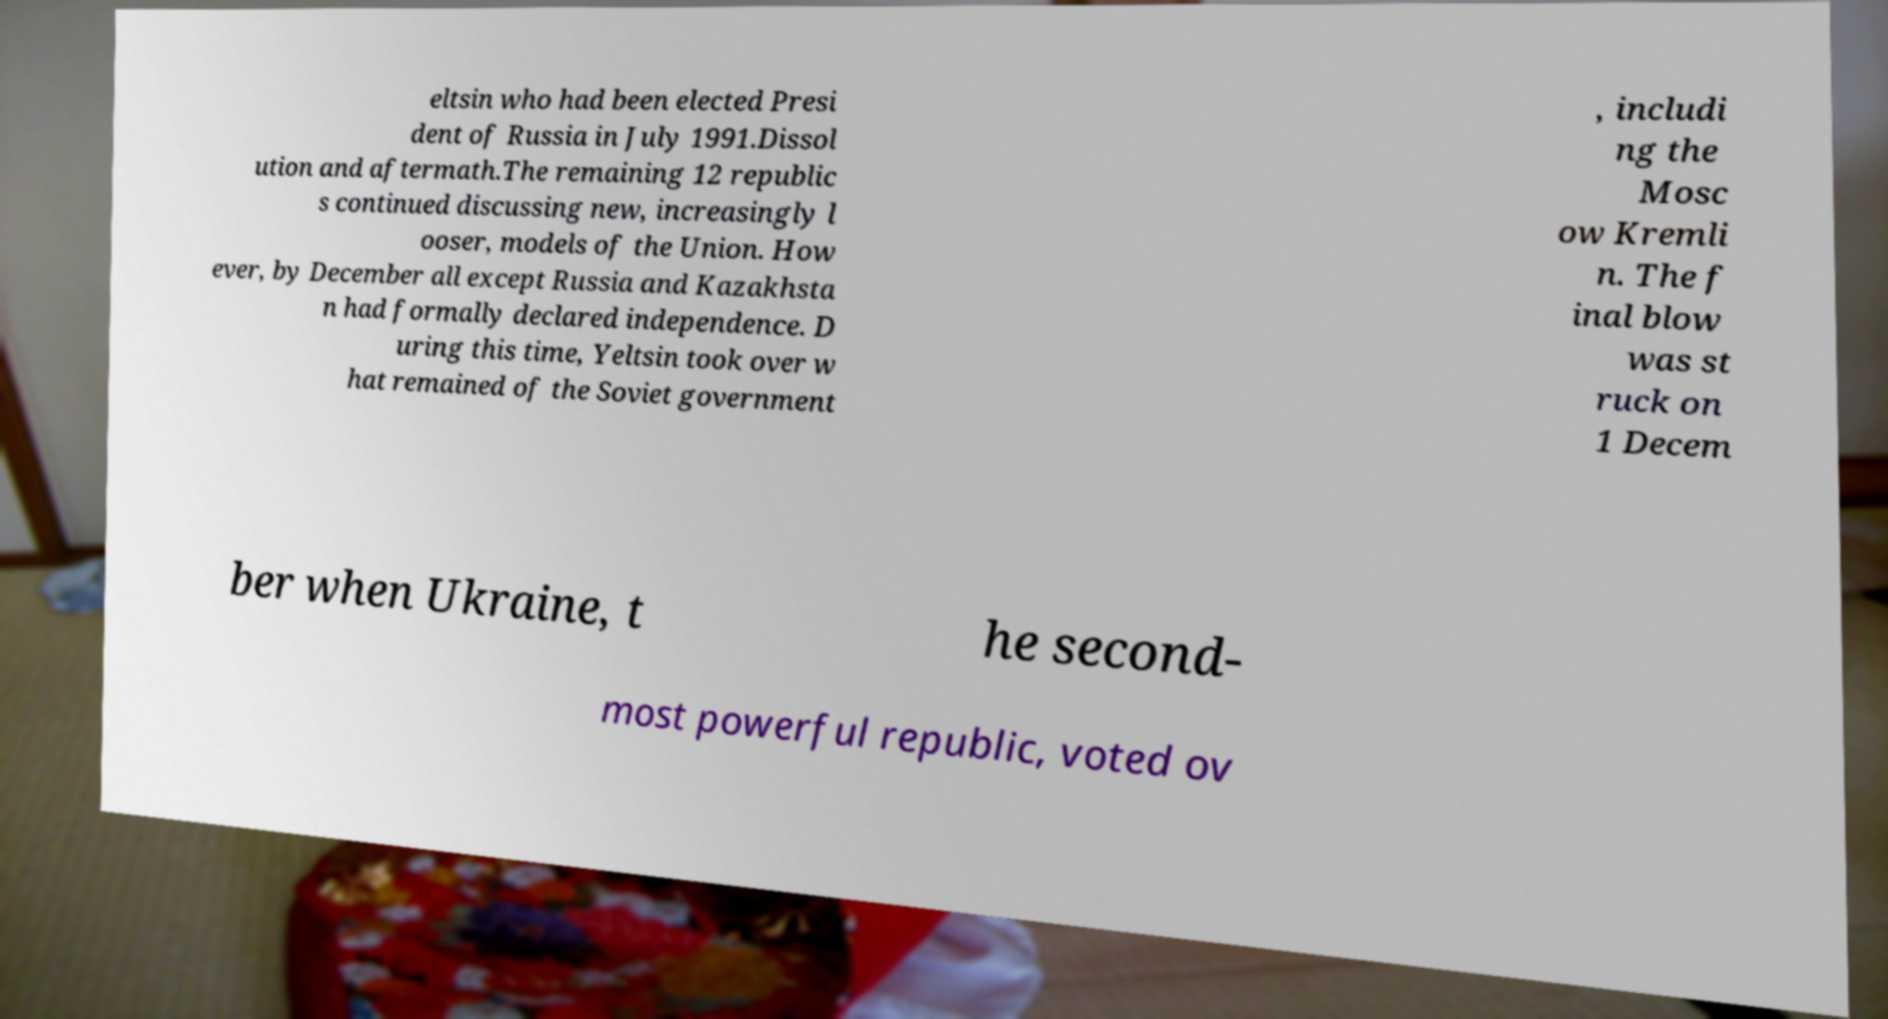I need the written content from this picture converted into text. Can you do that? eltsin who had been elected Presi dent of Russia in July 1991.Dissol ution and aftermath.The remaining 12 republic s continued discussing new, increasingly l ooser, models of the Union. How ever, by December all except Russia and Kazakhsta n had formally declared independence. D uring this time, Yeltsin took over w hat remained of the Soviet government , includi ng the Mosc ow Kremli n. The f inal blow was st ruck on 1 Decem ber when Ukraine, t he second- most powerful republic, voted ov 